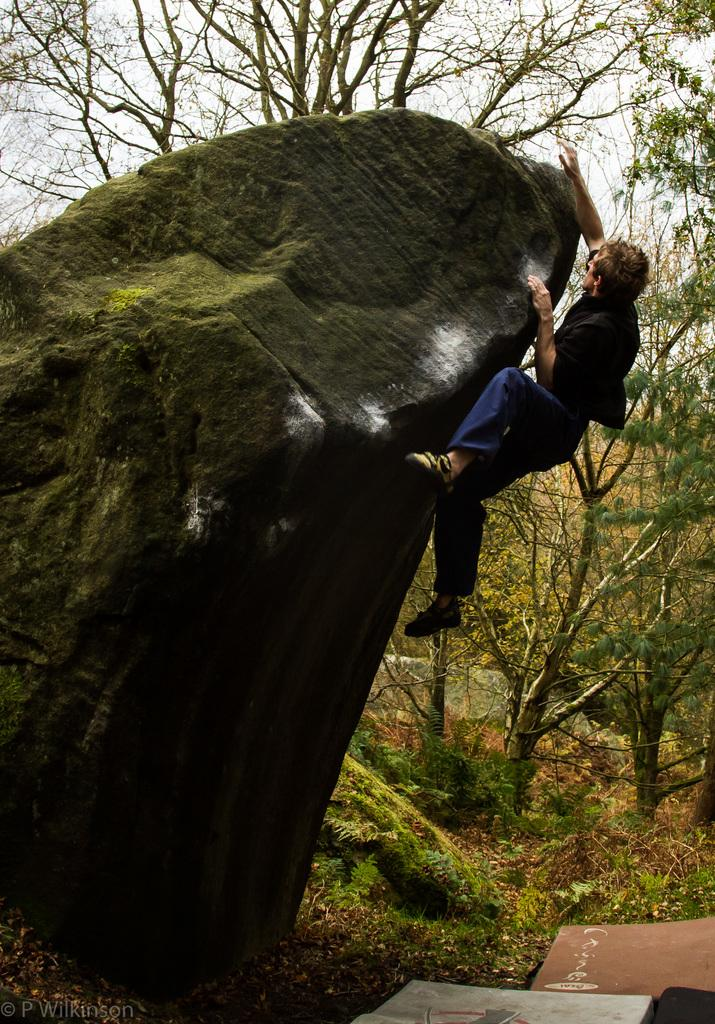What is the person in the image doing? There is a person climbing a rock in the image. What can be seen in the background of the image? There are trees in the background of the image. Is there any text present in the image? Yes, there is text at the bottom of the image. How much money is being exchanged between the climber and the trees in the image? There is no money being exchanged in the image; it features a person climbing a rock and trees in the background. 